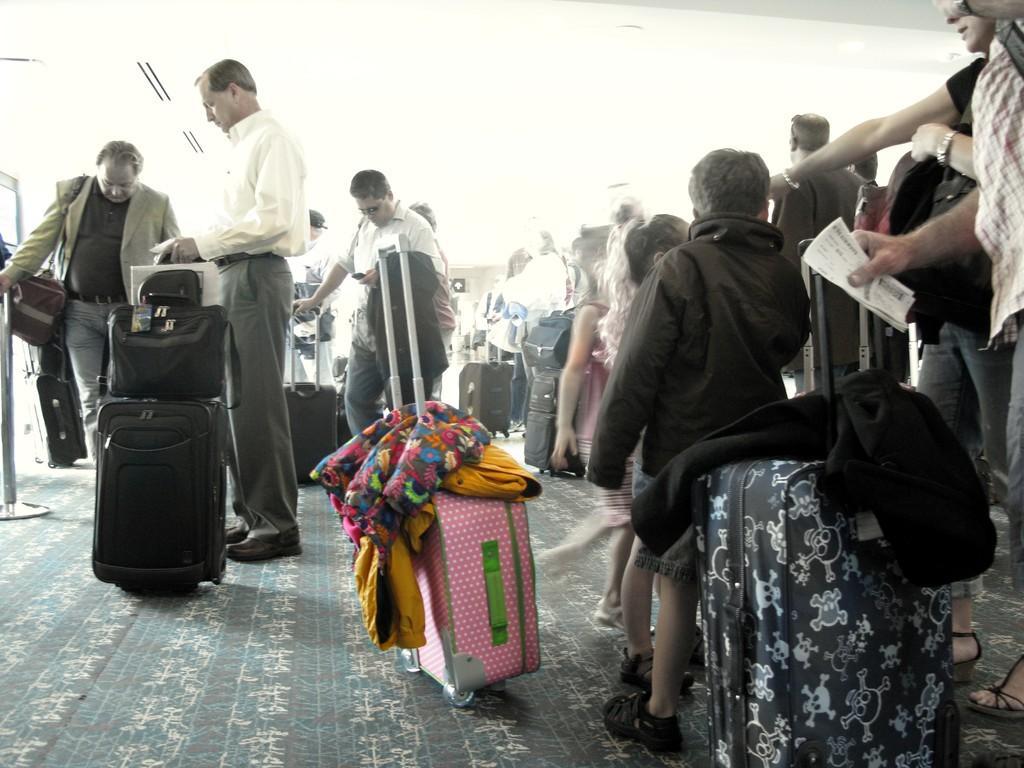Describe this image in one or two sentences. In this image we can see many people standing. Some are holding bags. There are many trolley bags. And there are clothes on the bags. 